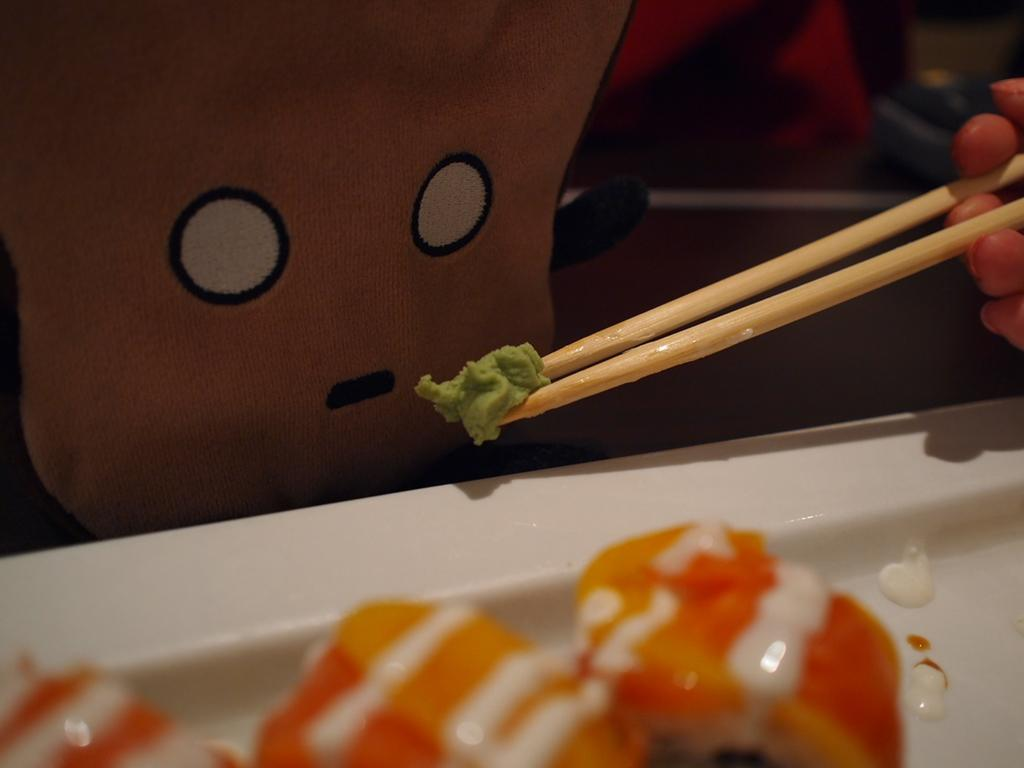What is present on the plate in the image? There is food on the plate in the image. Who is holding chopsticks and food in the image? There is a person holding chopsticks and food to the right in the image. What can be seen in the background of the image? There is a doll or emoji in the background of the image. How many houses are visible in the image? There are no houses visible in the image. Are there any books present in the image? There is no mention of books in the provided facts, and therefore we cannot determine if any are present in the image. 